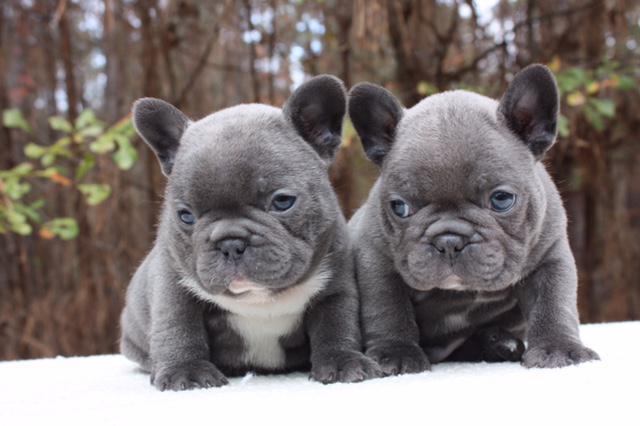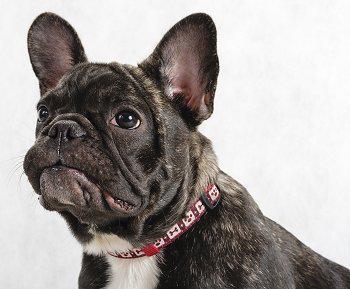The first image is the image on the left, the second image is the image on the right. Assess this claim about the two images: "An image contains exactly two side-by-side dogs, with a black one on the left and a white-bodied dog on the right.". Correct or not? Answer yes or no. No. The first image is the image on the left, the second image is the image on the right. Considering the images on both sides, is "The left image contains exactly two dogs that are seated next to each other." valid? Answer yes or no. Yes. 